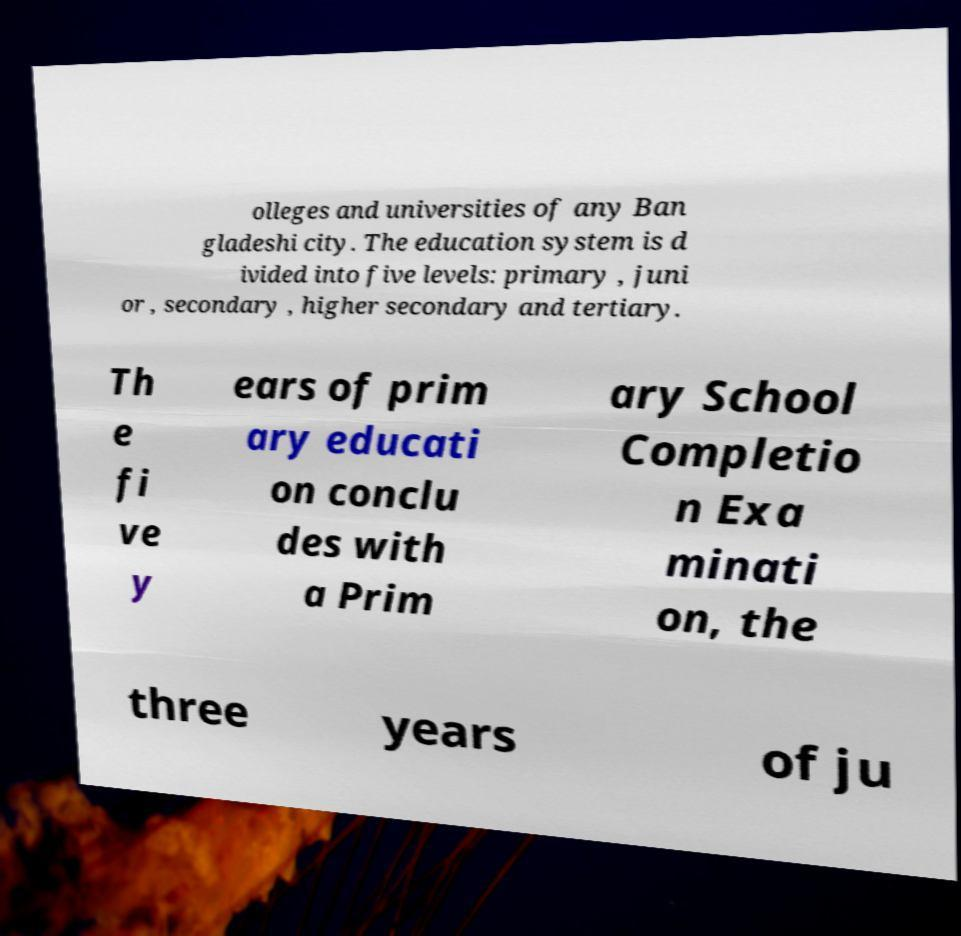I need the written content from this picture converted into text. Can you do that? olleges and universities of any Ban gladeshi city. The education system is d ivided into five levels: primary , juni or , secondary , higher secondary and tertiary. Th e fi ve y ears of prim ary educati on conclu des with a Prim ary School Completio n Exa minati on, the three years of ju 